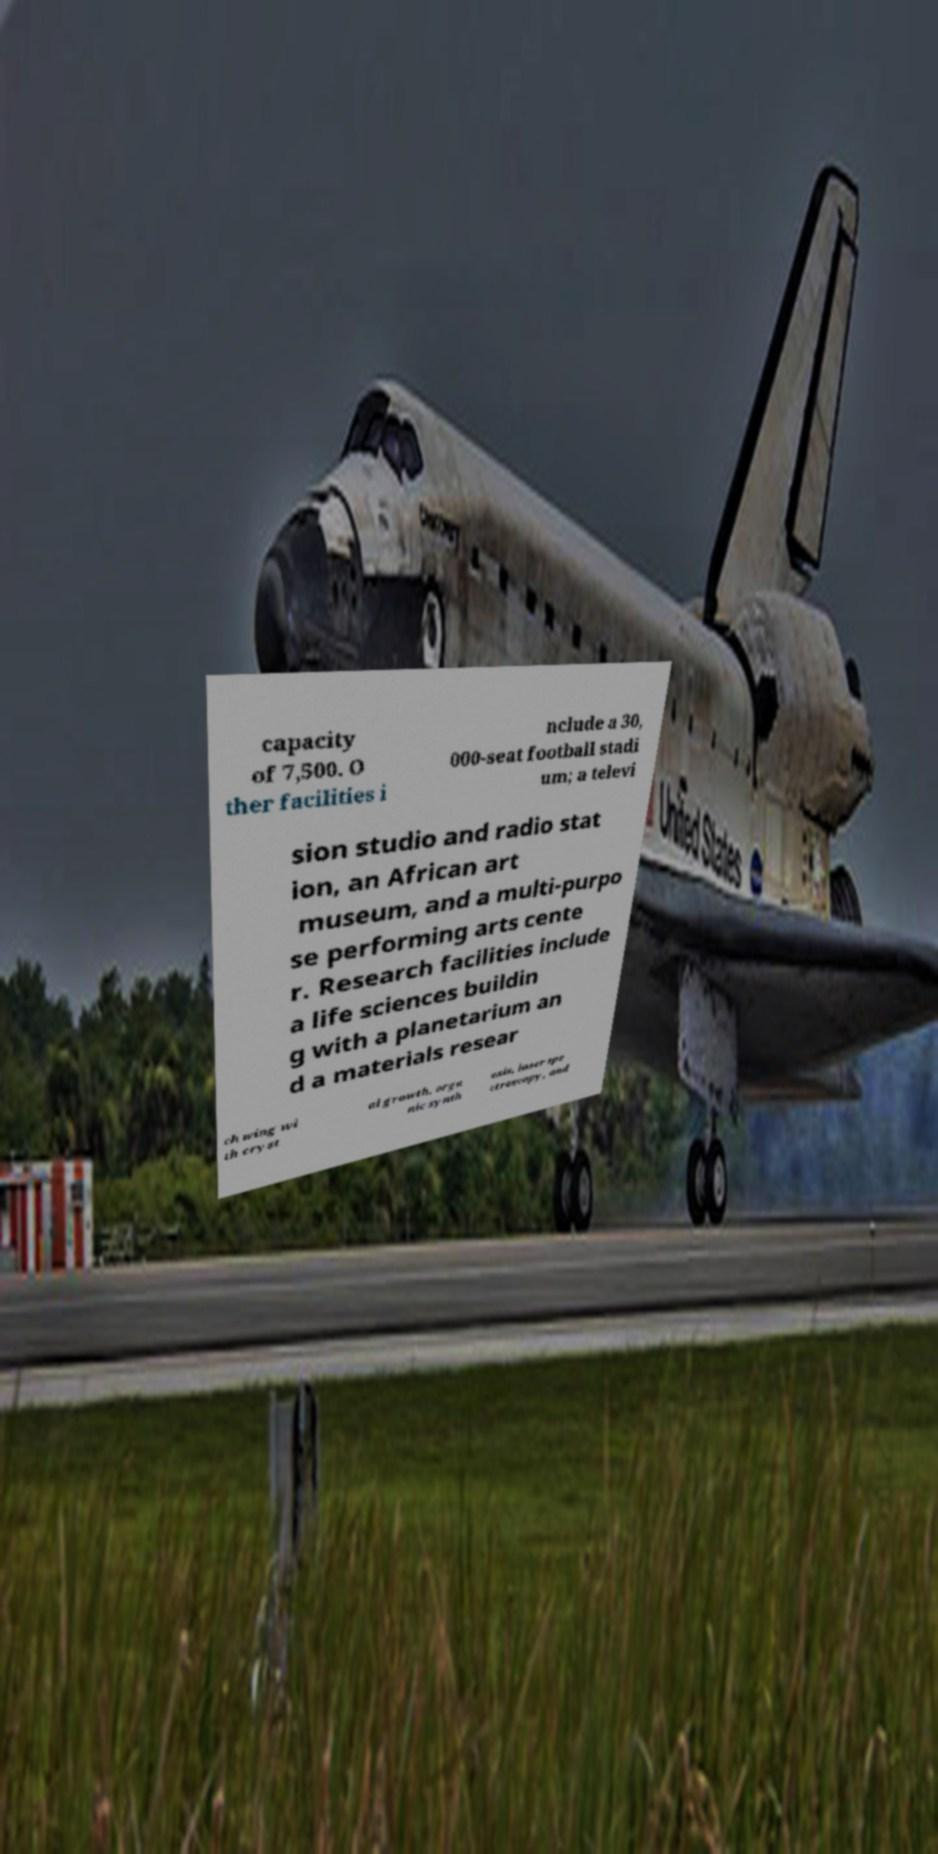There's text embedded in this image that I need extracted. Can you transcribe it verbatim? capacity of 7,500. O ther facilities i nclude a 30, 000-seat football stadi um; a televi sion studio and radio stat ion, an African art museum, and a multi-purpo se performing arts cente r. Research facilities include a life sciences buildin g with a planetarium an d a materials resear ch wing wi th cryst al growth, orga nic synth esis, laser spe ctroscopy, and 